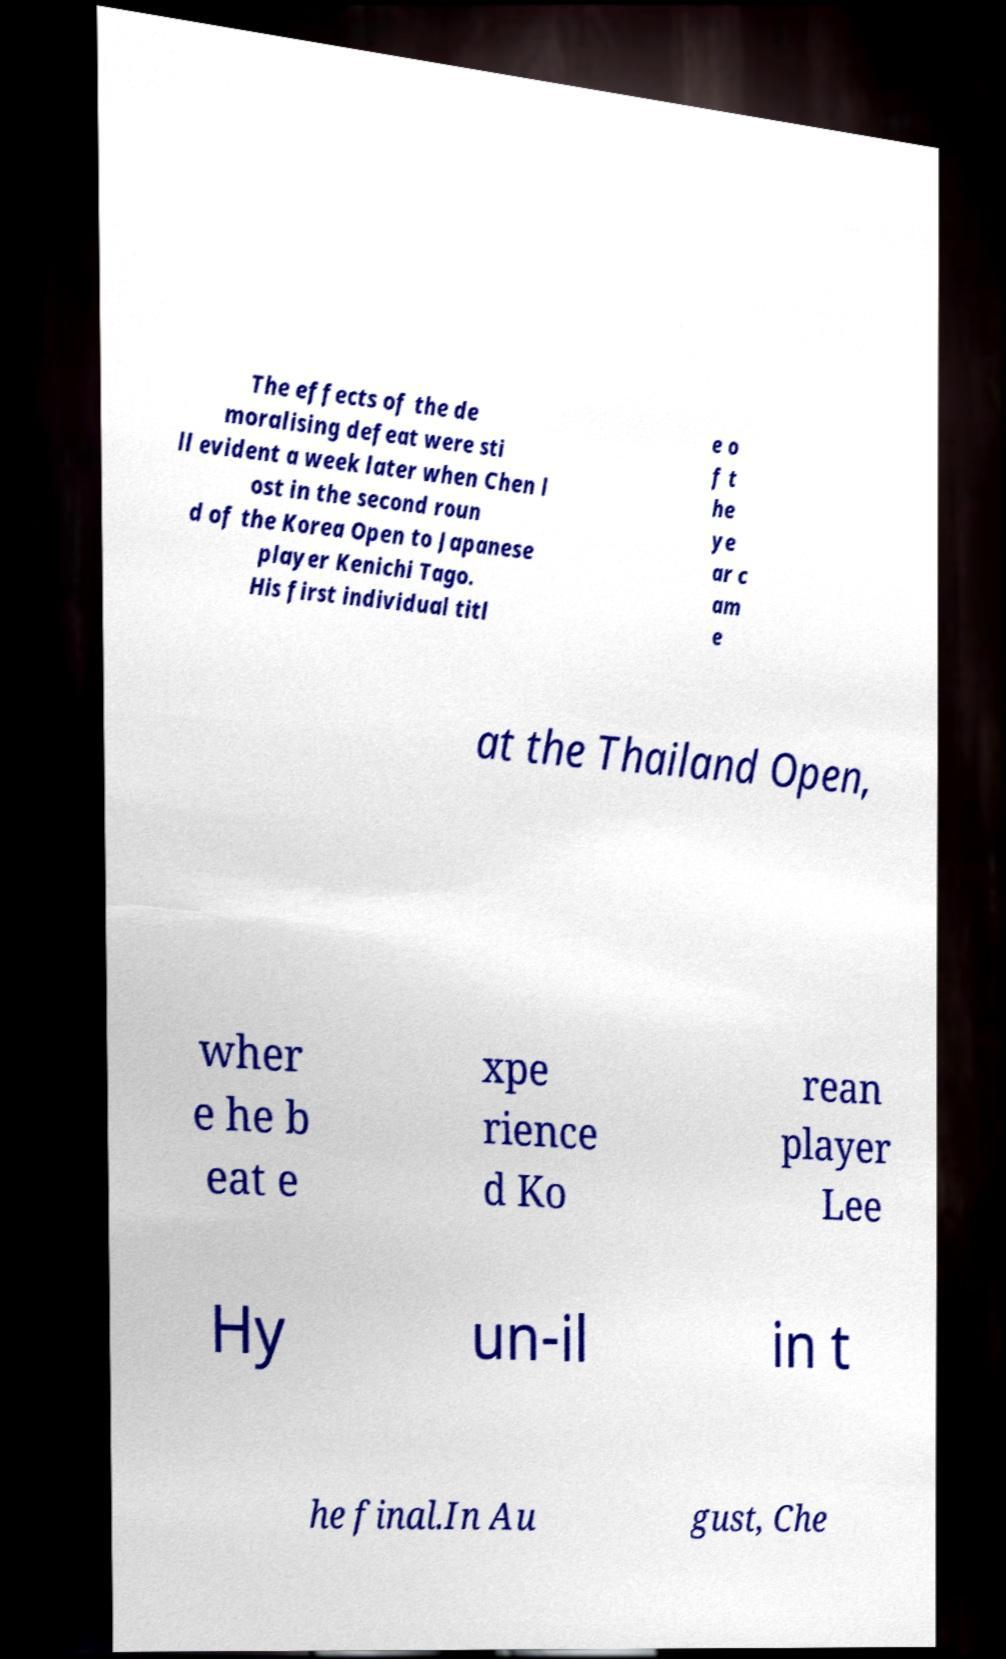Can you read and provide the text displayed in the image?This photo seems to have some interesting text. Can you extract and type it out for me? The effects of the de moralising defeat were sti ll evident a week later when Chen l ost in the second roun d of the Korea Open to Japanese player Kenichi Tago. His first individual titl e o f t he ye ar c am e at the Thailand Open, wher e he b eat e xpe rience d Ko rean player Lee Hy un-il in t he final.In Au gust, Che 